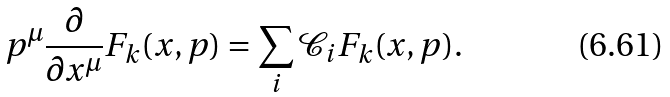Convert formula to latex. <formula><loc_0><loc_0><loc_500><loc_500>p ^ { \mu } \frac { \partial } { \partial x ^ { \mu } } F _ { k } ( x , p ) = \sum _ { i } \mathcal { C } _ { i } F _ { k } ( x , p ) .</formula> 